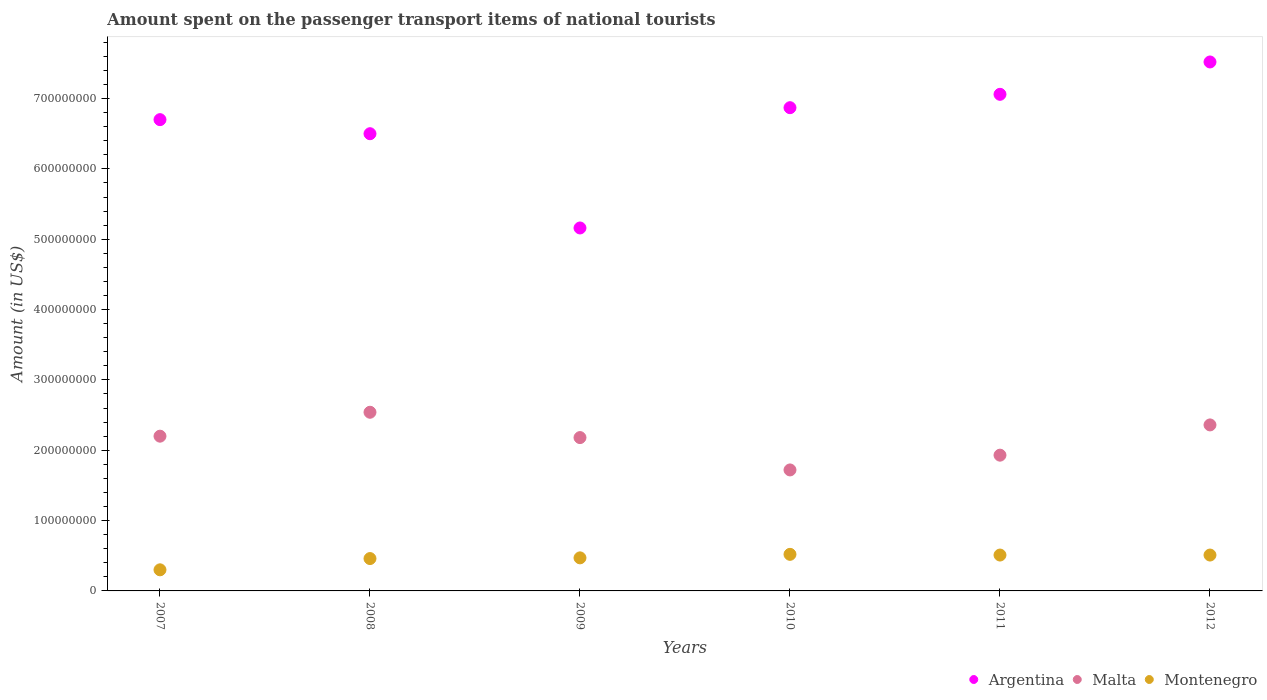What is the amount spent on the passenger transport items of national tourists in Argentina in 2011?
Keep it short and to the point. 7.06e+08. Across all years, what is the maximum amount spent on the passenger transport items of national tourists in Argentina?
Offer a terse response. 7.52e+08. Across all years, what is the minimum amount spent on the passenger transport items of national tourists in Argentina?
Keep it short and to the point. 5.16e+08. In which year was the amount spent on the passenger transport items of national tourists in Malta minimum?
Your answer should be very brief. 2010. What is the total amount spent on the passenger transport items of national tourists in Malta in the graph?
Your answer should be compact. 1.29e+09. What is the difference between the amount spent on the passenger transport items of national tourists in Argentina in 2008 and that in 2009?
Offer a very short reply. 1.34e+08. What is the difference between the amount spent on the passenger transport items of national tourists in Malta in 2008 and the amount spent on the passenger transport items of national tourists in Montenegro in 2007?
Your answer should be compact. 2.24e+08. What is the average amount spent on the passenger transport items of national tourists in Malta per year?
Offer a very short reply. 2.16e+08. In the year 2011, what is the difference between the amount spent on the passenger transport items of national tourists in Malta and amount spent on the passenger transport items of national tourists in Montenegro?
Offer a very short reply. 1.42e+08. In how many years, is the amount spent on the passenger transport items of national tourists in Argentina greater than 620000000 US$?
Keep it short and to the point. 5. What is the ratio of the amount spent on the passenger transport items of national tourists in Montenegro in 2008 to that in 2009?
Give a very brief answer. 0.98. Is the amount spent on the passenger transport items of national tourists in Montenegro in 2007 less than that in 2009?
Offer a very short reply. Yes. Is the difference between the amount spent on the passenger transport items of national tourists in Malta in 2007 and 2012 greater than the difference between the amount spent on the passenger transport items of national tourists in Montenegro in 2007 and 2012?
Give a very brief answer. Yes. What is the difference between the highest and the second highest amount spent on the passenger transport items of national tourists in Argentina?
Your answer should be compact. 4.60e+07. What is the difference between the highest and the lowest amount spent on the passenger transport items of national tourists in Montenegro?
Provide a short and direct response. 2.20e+07. Is the sum of the amount spent on the passenger transport items of national tourists in Argentina in 2007 and 2010 greater than the maximum amount spent on the passenger transport items of national tourists in Montenegro across all years?
Keep it short and to the point. Yes. Does the amount spent on the passenger transport items of national tourists in Malta monotonically increase over the years?
Ensure brevity in your answer.  No. Is the amount spent on the passenger transport items of national tourists in Argentina strictly greater than the amount spent on the passenger transport items of national tourists in Malta over the years?
Offer a terse response. Yes. How many dotlines are there?
Ensure brevity in your answer.  3. How many years are there in the graph?
Give a very brief answer. 6. Where does the legend appear in the graph?
Your answer should be very brief. Bottom right. How are the legend labels stacked?
Keep it short and to the point. Horizontal. What is the title of the graph?
Provide a short and direct response. Amount spent on the passenger transport items of national tourists. What is the label or title of the Y-axis?
Offer a very short reply. Amount (in US$). What is the Amount (in US$) in Argentina in 2007?
Provide a short and direct response. 6.70e+08. What is the Amount (in US$) in Malta in 2007?
Provide a short and direct response. 2.20e+08. What is the Amount (in US$) of Montenegro in 2007?
Provide a short and direct response. 3.00e+07. What is the Amount (in US$) in Argentina in 2008?
Give a very brief answer. 6.50e+08. What is the Amount (in US$) in Malta in 2008?
Provide a short and direct response. 2.54e+08. What is the Amount (in US$) of Montenegro in 2008?
Provide a succinct answer. 4.60e+07. What is the Amount (in US$) in Argentina in 2009?
Provide a succinct answer. 5.16e+08. What is the Amount (in US$) of Malta in 2009?
Offer a very short reply. 2.18e+08. What is the Amount (in US$) of Montenegro in 2009?
Keep it short and to the point. 4.70e+07. What is the Amount (in US$) in Argentina in 2010?
Offer a terse response. 6.87e+08. What is the Amount (in US$) of Malta in 2010?
Provide a succinct answer. 1.72e+08. What is the Amount (in US$) in Montenegro in 2010?
Make the answer very short. 5.20e+07. What is the Amount (in US$) of Argentina in 2011?
Offer a very short reply. 7.06e+08. What is the Amount (in US$) of Malta in 2011?
Ensure brevity in your answer.  1.93e+08. What is the Amount (in US$) of Montenegro in 2011?
Make the answer very short. 5.10e+07. What is the Amount (in US$) of Argentina in 2012?
Your answer should be compact. 7.52e+08. What is the Amount (in US$) of Malta in 2012?
Make the answer very short. 2.36e+08. What is the Amount (in US$) in Montenegro in 2012?
Your answer should be very brief. 5.10e+07. Across all years, what is the maximum Amount (in US$) in Argentina?
Give a very brief answer. 7.52e+08. Across all years, what is the maximum Amount (in US$) in Malta?
Your answer should be compact. 2.54e+08. Across all years, what is the maximum Amount (in US$) of Montenegro?
Keep it short and to the point. 5.20e+07. Across all years, what is the minimum Amount (in US$) in Argentina?
Keep it short and to the point. 5.16e+08. Across all years, what is the minimum Amount (in US$) in Malta?
Provide a succinct answer. 1.72e+08. Across all years, what is the minimum Amount (in US$) of Montenegro?
Your answer should be compact. 3.00e+07. What is the total Amount (in US$) of Argentina in the graph?
Your response must be concise. 3.98e+09. What is the total Amount (in US$) of Malta in the graph?
Provide a succinct answer. 1.29e+09. What is the total Amount (in US$) of Montenegro in the graph?
Keep it short and to the point. 2.77e+08. What is the difference between the Amount (in US$) of Argentina in 2007 and that in 2008?
Keep it short and to the point. 2.00e+07. What is the difference between the Amount (in US$) of Malta in 2007 and that in 2008?
Your response must be concise. -3.40e+07. What is the difference between the Amount (in US$) of Montenegro in 2007 and that in 2008?
Provide a short and direct response. -1.60e+07. What is the difference between the Amount (in US$) in Argentina in 2007 and that in 2009?
Offer a very short reply. 1.54e+08. What is the difference between the Amount (in US$) in Montenegro in 2007 and that in 2009?
Your answer should be compact. -1.70e+07. What is the difference between the Amount (in US$) of Argentina in 2007 and that in 2010?
Make the answer very short. -1.70e+07. What is the difference between the Amount (in US$) in Malta in 2007 and that in 2010?
Give a very brief answer. 4.80e+07. What is the difference between the Amount (in US$) of Montenegro in 2007 and that in 2010?
Your response must be concise. -2.20e+07. What is the difference between the Amount (in US$) in Argentina in 2007 and that in 2011?
Your answer should be compact. -3.60e+07. What is the difference between the Amount (in US$) in Malta in 2007 and that in 2011?
Offer a very short reply. 2.70e+07. What is the difference between the Amount (in US$) in Montenegro in 2007 and that in 2011?
Offer a terse response. -2.10e+07. What is the difference between the Amount (in US$) of Argentina in 2007 and that in 2012?
Ensure brevity in your answer.  -8.20e+07. What is the difference between the Amount (in US$) in Malta in 2007 and that in 2012?
Offer a very short reply. -1.60e+07. What is the difference between the Amount (in US$) of Montenegro in 2007 and that in 2012?
Your response must be concise. -2.10e+07. What is the difference between the Amount (in US$) in Argentina in 2008 and that in 2009?
Provide a short and direct response. 1.34e+08. What is the difference between the Amount (in US$) of Malta in 2008 and that in 2009?
Provide a succinct answer. 3.60e+07. What is the difference between the Amount (in US$) in Montenegro in 2008 and that in 2009?
Provide a short and direct response. -1.00e+06. What is the difference between the Amount (in US$) in Argentina in 2008 and that in 2010?
Offer a terse response. -3.70e+07. What is the difference between the Amount (in US$) in Malta in 2008 and that in 2010?
Provide a succinct answer. 8.20e+07. What is the difference between the Amount (in US$) of Montenegro in 2008 and that in 2010?
Offer a terse response. -6.00e+06. What is the difference between the Amount (in US$) of Argentina in 2008 and that in 2011?
Your answer should be compact. -5.60e+07. What is the difference between the Amount (in US$) of Malta in 2008 and that in 2011?
Offer a terse response. 6.10e+07. What is the difference between the Amount (in US$) of Montenegro in 2008 and that in 2011?
Provide a short and direct response. -5.00e+06. What is the difference between the Amount (in US$) in Argentina in 2008 and that in 2012?
Your response must be concise. -1.02e+08. What is the difference between the Amount (in US$) of Malta in 2008 and that in 2012?
Provide a succinct answer. 1.80e+07. What is the difference between the Amount (in US$) of Montenegro in 2008 and that in 2012?
Provide a short and direct response. -5.00e+06. What is the difference between the Amount (in US$) in Argentina in 2009 and that in 2010?
Offer a terse response. -1.71e+08. What is the difference between the Amount (in US$) of Malta in 2009 and that in 2010?
Keep it short and to the point. 4.60e+07. What is the difference between the Amount (in US$) of Montenegro in 2009 and that in 2010?
Provide a succinct answer. -5.00e+06. What is the difference between the Amount (in US$) of Argentina in 2009 and that in 2011?
Provide a short and direct response. -1.90e+08. What is the difference between the Amount (in US$) of Malta in 2009 and that in 2011?
Provide a short and direct response. 2.50e+07. What is the difference between the Amount (in US$) of Argentina in 2009 and that in 2012?
Give a very brief answer. -2.36e+08. What is the difference between the Amount (in US$) in Malta in 2009 and that in 2012?
Offer a very short reply. -1.80e+07. What is the difference between the Amount (in US$) in Montenegro in 2009 and that in 2012?
Your response must be concise. -4.00e+06. What is the difference between the Amount (in US$) in Argentina in 2010 and that in 2011?
Make the answer very short. -1.90e+07. What is the difference between the Amount (in US$) of Malta in 2010 and that in 2011?
Give a very brief answer. -2.10e+07. What is the difference between the Amount (in US$) in Argentina in 2010 and that in 2012?
Give a very brief answer. -6.50e+07. What is the difference between the Amount (in US$) of Malta in 2010 and that in 2012?
Keep it short and to the point. -6.40e+07. What is the difference between the Amount (in US$) of Argentina in 2011 and that in 2012?
Offer a terse response. -4.60e+07. What is the difference between the Amount (in US$) in Malta in 2011 and that in 2012?
Your answer should be very brief. -4.30e+07. What is the difference between the Amount (in US$) in Montenegro in 2011 and that in 2012?
Your answer should be very brief. 0. What is the difference between the Amount (in US$) of Argentina in 2007 and the Amount (in US$) of Malta in 2008?
Keep it short and to the point. 4.16e+08. What is the difference between the Amount (in US$) in Argentina in 2007 and the Amount (in US$) in Montenegro in 2008?
Offer a very short reply. 6.24e+08. What is the difference between the Amount (in US$) of Malta in 2007 and the Amount (in US$) of Montenegro in 2008?
Provide a short and direct response. 1.74e+08. What is the difference between the Amount (in US$) in Argentina in 2007 and the Amount (in US$) in Malta in 2009?
Ensure brevity in your answer.  4.52e+08. What is the difference between the Amount (in US$) of Argentina in 2007 and the Amount (in US$) of Montenegro in 2009?
Keep it short and to the point. 6.23e+08. What is the difference between the Amount (in US$) in Malta in 2007 and the Amount (in US$) in Montenegro in 2009?
Provide a short and direct response. 1.73e+08. What is the difference between the Amount (in US$) of Argentina in 2007 and the Amount (in US$) of Malta in 2010?
Ensure brevity in your answer.  4.98e+08. What is the difference between the Amount (in US$) of Argentina in 2007 and the Amount (in US$) of Montenegro in 2010?
Your response must be concise. 6.18e+08. What is the difference between the Amount (in US$) in Malta in 2007 and the Amount (in US$) in Montenegro in 2010?
Offer a very short reply. 1.68e+08. What is the difference between the Amount (in US$) of Argentina in 2007 and the Amount (in US$) of Malta in 2011?
Your response must be concise. 4.77e+08. What is the difference between the Amount (in US$) in Argentina in 2007 and the Amount (in US$) in Montenegro in 2011?
Your answer should be very brief. 6.19e+08. What is the difference between the Amount (in US$) in Malta in 2007 and the Amount (in US$) in Montenegro in 2011?
Offer a terse response. 1.69e+08. What is the difference between the Amount (in US$) of Argentina in 2007 and the Amount (in US$) of Malta in 2012?
Give a very brief answer. 4.34e+08. What is the difference between the Amount (in US$) in Argentina in 2007 and the Amount (in US$) in Montenegro in 2012?
Offer a very short reply. 6.19e+08. What is the difference between the Amount (in US$) of Malta in 2007 and the Amount (in US$) of Montenegro in 2012?
Ensure brevity in your answer.  1.69e+08. What is the difference between the Amount (in US$) of Argentina in 2008 and the Amount (in US$) of Malta in 2009?
Your answer should be very brief. 4.32e+08. What is the difference between the Amount (in US$) of Argentina in 2008 and the Amount (in US$) of Montenegro in 2009?
Provide a short and direct response. 6.03e+08. What is the difference between the Amount (in US$) of Malta in 2008 and the Amount (in US$) of Montenegro in 2009?
Provide a short and direct response. 2.07e+08. What is the difference between the Amount (in US$) in Argentina in 2008 and the Amount (in US$) in Malta in 2010?
Provide a succinct answer. 4.78e+08. What is the difference between the Amount (in US$) in Argentina in 2008 and the Amount (in US$) in Montenegro in 2010?
Ensure brevity in your answer.  5.98e+08. What is the difference between the Amount (in US$) of Malta in 2008 and the Amount (in US$) of Montenegro in 2010?
Provide a short and direct response. 2.02e+08. What is the difference between the Amount (in US$) in Argentina in 2008 and the Amount (in US$) in Malta in 2011?
Offer a very short reply. 4.57e+08. What is the difference between the Amount (in US$) in Argentina in 2008 and the Amount (in US$) in Montenegro in 2011?
Give a very brief answer. 5.99e+08. What is the difference between the Amount (in US$) in Malta in 2008 and the Amount (in US$) in Montenegro in 2011?
Your response must be concise. 2.03e+08. What is the difference between the Amount (in US$) in Argentina in 2008 and the Amount (in US$) in Malta in 2012?
Keep it short and to the point. 4.14e+08. What is the difference between the Amount (in US$) in Argentina in 2008 and the Amount (in US$) in Montenegro in 2012?
Provide a succinct answer. 5.99e+08. What is the difference between the Amount (in US$) of Malta in 2008 and the Amount (in US$) of Montenegro in 2012?
Provide a short and direct response. 2.03e+08. What is the difference between the Amount (in US$) in Argentina in 2009 and the Amount (in US$) in Malta in 2010?
Your response must be concise. 3.44e+08. What is the difference between the Amount (in US$) in Argentina in 2009 and the Amount (in US$) in Montenegro in 2010?
Your answer should be very brief. 4.64e+08. What is the difference between the Amount (in US$) of Malta in 2009 and the Amount (in US$) of Montenegro in 2010?
Provide a short and direct response. 1.66e+08. What is the difference between the Amount (in US$) of Argentina in 2009 and the Amount (in US$) of Malta in 2011?
Your response must be concise. 3.23e+08. What is the difference between the Amount (in US$) of Argentina in 2009 and the Amount (in US$) of Montenegro in 2011?
Ensure brevity in your answer.  4.65e+08. What is the difference between the Amount (in US$) in Malta in 2009 and the Amount (in US$) in Montenegro in 2011?
Provide a short and direct response. 1.67e+08. What is the difference between the Amount (in US$) in Argentina in 2009 and the Amount (in US$) in Malta in 2012?
Give a very brief answer. 2.80e+08. What is the difference between the Amount (in US$) of Argentina in 2009 and the Amount (in US$) of Montenegro in 2012?
Provide a succinct answer. 4.65e+08. What is the difference between the Amount (in US$) of Malta in 2009 and the Amount (in US$) of Montenegro in 2012?
Keep it short and to the point. 1.67e+08. What is the difference between the Amount (in US$) of Argentina in 2010 and the Amount (in US$) of Malta in 2011?
Your answer should be very brief. 4.94e+08. What is the difference between the Amount (in US$) in Argentina in 2010 and the Amount (in US$) in Montenegro in 2011?
Provide a succinct answer. 6.36e+08. What is the difference between the Amount (in US$) in Malta in 2010 and the Amount (in US$) in Montenegro in 2011?
Offer a terse response. 1.21e+08. What is the difference between the Amount (in US$) in Argentina in 2010 and the Amount (in US$) in Malta in 2012?
Your answer should be very brief. 4.51e+08. What is the difference between the Amount (in US$) in Argentina in 2010 and the Amount (in US$) in Montenegro in 2012?
Offer a terse response. 6.36e+08. What is the difference between the Amount (in US$) of Malta in 2010 and the Amount (in US$) of Montenegro in 2012?
Make the answer very short. 1.21e+08. What is the difference between the Amount (in US$) in Argentina in 2011 and the Amount (in US$) in Malta in 2012?
Ensure brevity in your answer.  4.70e+08. What is the difference between the Amount (in US$) of Argentina in 2011 and the Amount (in US$) of Montenegro in 2012?
Give a very brief answer. 6.55e+08. What is the difference between the Amount (in US$) of Malta in 2011 and the Amount (in US$) of Montenegro in 2012?
Provide a succinct answer. 1.42e+08. What is the average Amount (in US$) in Argentina per year?
Offer a terse response. 6.64e+08. What is the average Amount (in US$) of Malta per year?
Offer a very short reply. 2.16e+08. What is the average Amount (in US$) of Montenegro per year?
Your answer should be very brief. 4.62e+07. In the year 2007, what is the difference between the Amount (in US$) in Argentina and Amount (in US$) in Malta?
Make the answer very short. 4.50e+08. In the year 2007, what is the difference between the Amount (in US$) of Argentina and Amount (in US$) of Montenegro?
Provide a succinct answer. 6.40e+08. In the year 2007, what is the difference between the Amount (in US$) of Malta and Amount (in US$) of Montenegro?
Your answer should be compact. 1.90e+08. In the year 2008, what is the difference between the Amount (in US$) of Argentina and Amount (in US$) of Malta?
Provide a short and direct response. 3.96e+08. In the year 2008, what is the difference between the Amount (in US$) of Argentina and Amount (in US$) of Montenegro?
Provide a short and direct response. 6.04e+08. In the year 2008, what is the difference between the Amount (in US$) in Malta and Amount (in US$) in Montenegro?
Provide a short and direct response. 2.08e+08. In the year 2009, what is the difference between the Amount (in US$) of Argentina and Amount (in US$) of Malta?
Your answer should be very brief. 2.98e+08. In the year 2009, what is the difference between the Amount (in US$) of Argentina and Amount (in US$) of Montenegro?
Provide a short and direct response. 4.69e+08. In the year 2009, what is the difference between the Amount (in US$) in Malta and Amount (in US$) in Montenegro?
Provide a short and direct response. 1.71e+08. In the year 2010, what is the difference between the Amount (in US$) of Argentina and Amount (in US$) of Malta?
Your answer should be very brief. 5.15e+08. In the year 2010, what is the difference between the Amount (in US$) in Argentina and Amount (in US$) in Montenegro?
Make the answer very short. 6.35e+08. In the year 2010, what is the difference between the Amount (in US$) of Malta and Amount (in US$) of Montenegro?
Give a very brief answer. 1.20e+08. In the year 2011, what is the difference between the Amount (in US$) in Argentina and Amount (in US$) in Malta?
Your answer should be very brief. 5.13e+08. In the year 2011, what is the difference between the Amount (in US$) in Argentina and Amount (in US$) in Montenegro?
Ensure brevity in your answer.  6.55e+08. In the year 2011, what is the difference between the Amount (in US$) of Malta and Amount (in US$) of Montenegro?
Offer a very short reply. 1.42e+08. In the year 2012, what is the difference between the Amount (in US$) in Argentina and Amount (in US$) in Malta?
Offer a terse response. 5.16e+08. In the year 2012, what is the difference between the Amount (in US$) in Argentina and Amount (in US$) in Montenegro?
Keep it short and to the point. 7.01e+08. In the year 2012, what is the difference between the Amount (in US$) in Malta and Amount (in US$) in Montenegro?
Offer a very short reply. 1.85e+08. What is the ratio of the Amount (in US$) of Argentina in 2007 to that in 2008?
Ensure brevity in your answer.  1.03. What is the ratio of the Amount (in US$) of Malta in 2007 to that in 2008?
Provide a succinct answer. 0.87. What is the ratio of the Amount (in US$) of Montenegro in 2007 to that in 2008?
Make the answer very short. 0.65. What is the ratio of the Amount (in US$) in Argentina in 2007 to that in 2009?
Make the answer very short. 1.3. What is the ratio of the Amount (in US$) in Malta in 2007 to that in 2009?
Your answer should be compact. 1.01. What is the ratio of the Amount (in US$) of Montenegro in 2007 to that in 2009?
Keep it short and to the point. 0.64. What is the ratio of the Amount (in US$) of Argentina in 2007 to that in 2010?
Give a very brief answer. 0.98. What is the ratio of the Amount (in US$) in Malta in 2007 to that in 2010?
Give a very brief answer. 1.28. What is the ratio of the Amount (in US$) in Montenegro in 2007 to that in 2010?
Make the answer very short. 0.58. What is the ratio of the Amount (in US$) in Argentina in 2007 to that in 2011?
Ensure brevity in your answer.  0.95. What is the ratio of the Amount (in US$) of Malta in 2007 to that in 2011?
Keep it short and to the point. 1.14. What is the ratio of the Amount (in US$) in Montenegro in 2007 to that in 2011?
Give a very brief answer. 0.59. What is the ratio of the Amount (in US$) in Argentina in 2007 to that in 2012?
Keep it short and to the point. 0.89. What is the ratio of the Amount (in US$) of Malta in 2007 to that in 2012?
Give a very brief answer. 0.93. What is the ratio of the Amount (in US$) of Montenegro in 2007 to that in 2012?
Your answer should be very brief. 0.59. What is the ratio of the Amount (in US$) of Argentina in 2008 to that in 2009?
Your response must be concise. 1.26. What is the ratio of the Amount (in US$) of Malta in 2008 to that in 2009?
Provide a succinct answer. 1.17. What is the ratio of the Amount (in US$) in Montenegro in 2008 to that in 2009?
Provide a short and direct response. 0.98. What is the ratio of the Amount (in US$) in Argentina in 2008 to that in 2010?
Your response must be concise. 0.95. What is the ratio of the Amount (in US$) in Malta in 2008 to that in 2010?
Ensure brevity in your answer.  1.48. What is the ratio of the Amount (in US$) in Montenegro in 2008 to that in 2010?
Your response must be concise. 0.88. What is the ratio of the Amount (in US$) of Argentina in 2008 to that in 2011?
Your response must be concise. 0.92. What is the ratio of the Amount (in US$) in Malta in 2008 to that in 2011?
Your answer should be compact. 1.32. What is the ratio of the Amount (in US$) in Montenegro in 2008 to that in 2011?
Provide a succinct answer. 0.9. What is the ratio of the Amount (in US$) in Argentina in 2008 to that in 2012?
Keep it short and to the point. 0.86. What is the ratio of the Amount (in US$) of Malta in 2008 to that in 2012?
Keep it short and to the point. 1.08. What is the ratio of the Amount (in US$) of Montenegro in 2008 to that in 2012?
Provide a short and direct response. 0.9. What is the ratio of the Amount (in US$) in Argentina in 2009 to that in 2010?
Ensure brevity in your answer.  0.75. What is the ratio of the Amount (in US$) of Malta in 2009 to that in 2010?
Your answer should be compact. 1.27. What is the ratio of the Amount (in US$) of Montenegro in 2009 to that in 2010?
Ensure brevity in your answer.  0.9. What is the ratio of the Amount (in US$) in Argentina in 2009 to that in 2011?
Give a very brief answer. 0.73. What is the ratio of the Amount (in US$) of Malta in 2009 to that in 2011?
Offer a terse response. 1.13. What is the ratio of the Amount (in US$) of Montenegro in 2009 to that in 2011?
Give a very brief answer. 0.92. What is the ratio of the Amount (in US$) in Argentina in 2009 to that in 2012?
Provide a succinct answer. 0.69. What is the ratio of the Amount (in US$) of Malta in 2009 to that in 2012?
Offer a very short reply. 0.92. What is the ratio of the Amount (in US$) of Montenegro in 2009 to that in 2012?
Make the answer very short. 0.92. What is the ratio of the Amount (in US$) of Argentina in 2010 to that in 2011?
Offer a very short reply. 0.97. What is the ratio of the Amount (in US$) of Malta in 2010 to that in 2011?
Offer a very short reply. 0.89. What is the ratio of the Amount (in US$) in Montenegro in 2010 to that in 2011?
Ensure brevity in your answer.  1.02. What is the ratio of the Amount (in US$) in Argentina in 2010 to that in 2012?
Give a very brief answer. 0.91. What is the ratio of the Amount (in US$) of Malta in 2010 to that in 2012?
Your response must be concise. 0.73. What is the ratio of the Amount (in US$) of Montenegro in 2010 to that in 2012?
Provide a succinct answer. 1.02. What is the ratio of the Amount (in US$) in Argentina in 2011 to that in 2012?
Your answer should be compact. 0.94. What is the ratio of the Amount (in US$) in Malta in 2011 to that in 2012?
Your response must be concise. 0.82. What is the difference between the highest and the second highest Amount (in US$) of Argentina?
Your answer should be very brief. 4.60e+07. What is the difference between the highest and the second highest Amount (in US$) in Malta?
Offer a very short reply. 1.80e+07. What is the difference between the highest and the lowest Amount (in US$) in Argentina?
Your answer should be compact. 2.36e+08. What is the difference between the highest and the lowest Amount (in US$) in Malta?
Ensure brevity in your answer.  8.20e+07. What is the difference between the highest and the lowest Amount (in US$) of Montenegro?
Offer a terse response. 2.20e+07. 